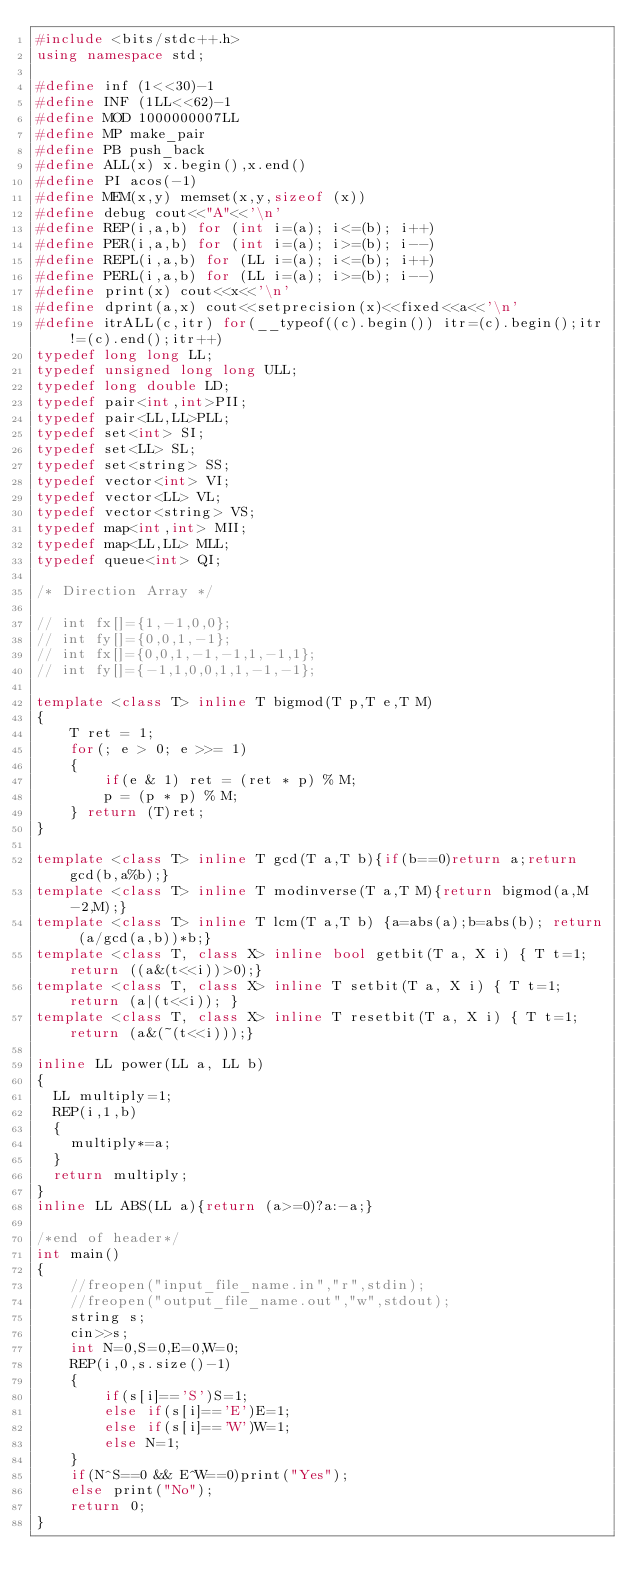<code> <loc_0><loc_0><loc_500><loc_500><_C++_>#include <bits/stdc++.h>
using namespace std;

#define inf (1<<30)-1
#define INF (1LL<<62)-1
#define MOD 1000000007LL
#define MP make_pair
#define PB push_back
#define ALL(x) x.begin(),x.end()
#define PI acos(-1)
#define MEM(x,y) memset(x,y,sizeof (x))
#define debug cout<<"A"<<'\n'
#define REP(i,a,b) for (int i=(a); i<=(b); i++)
#define PER(i,a,b) for (int i=(a); i>=(b); i--)
#define REPL(i,a,b) for (LL i=(a); i<=(b); i++)
#define PERL(i,a,b) for (LL i=(a); i>=(b); i--)
#define print(x) cout<<x<<'\n'
#define dprint(a,x) cout<<setprecision(x)<<fixed<<a<<'\n'
#define itrALL(c,itr) for(__typeof((c).begin()) itr=(c).begin();itr!=(c).end();itr++)
typedef long long LL;
typedef unsigned long long ULL;
typedef long double LD;
typedef pair<int,int>PII;
typedef pair<LL,LL>PLL;
typedef set<int> SI;
typedef set<LL> SL;
typedef set<string> SS;
typedef vector<int> VI;
typedef vector<LL> VL;
typedef vector<string> VS;
typedef map<int,int> MII;
typedef map<LL,LL> MLL;
typedef queue<int> QI;

/* Direction Array */

// int fx[]={1,-1,0,0};
// int fy[]={0,0,1,-1};
// int fx[]={0,0,1,-1,-1,1,-1,1};
// int fy[]={-1,1,0,0,1,1,-1,-1};

template <class T> inline T bigmod(T p,T e,T M)
{
    T ret = 1;
    for(; e > 0; e >>= 1)
    {
        if(e & 1) ret = (ret * p) % M;
        p = (p * p) % M;
    } return (T)ret;
}

template <class T> inline T gcd(T a,T b){if(b==0)return a;return gcd(b,a%b);}
template <class T> inline T modinverse(T a,T M){return bigmod(a,M-2,M);}
template <class T> inline T lcm(T a,T b) {a=abs(a);b=abs(b); return (a/gcd(a,b))*b;}
template <class T, class X> inline bool getbit(T a, X i) { T t=1; return ((a&(t<<i))>0);}
template <class T, class X> inline T setbit(T a, X i) { T t=1;return (a|(t<<i)); }
template <class T, class X> inline T resetbit(T a, X i) { T t=1;return (a&(~(t<<i)));}

inline LL power(LL a, LL b)
{
	LL multiply=1;
	REP(i,1,b)
	{
		multiply*=a;
	}
	return multiply;
}
inline LL ABS(LL a){return (a>=0)?a:-a;}

/*end of header*/
int main()
{
    //freopen("input_file_name.in","r",stdin);
    //freopen("output_file_name.out","w",stdout);
    string s;
    cin>>s;
    int N=0,S=0,E=0,W=0;
    REP(i,0,s.size()-1)
    {
        if(s[i]=='S')S=1;
        else if(s[i]=='E')E=1;
        else if(s[i]=='W')W=1;
        else N=1;
    }
    if(N^S==0 && E^W==0)print("Yes");
    else print("No");
    return 0;
}

</code> 